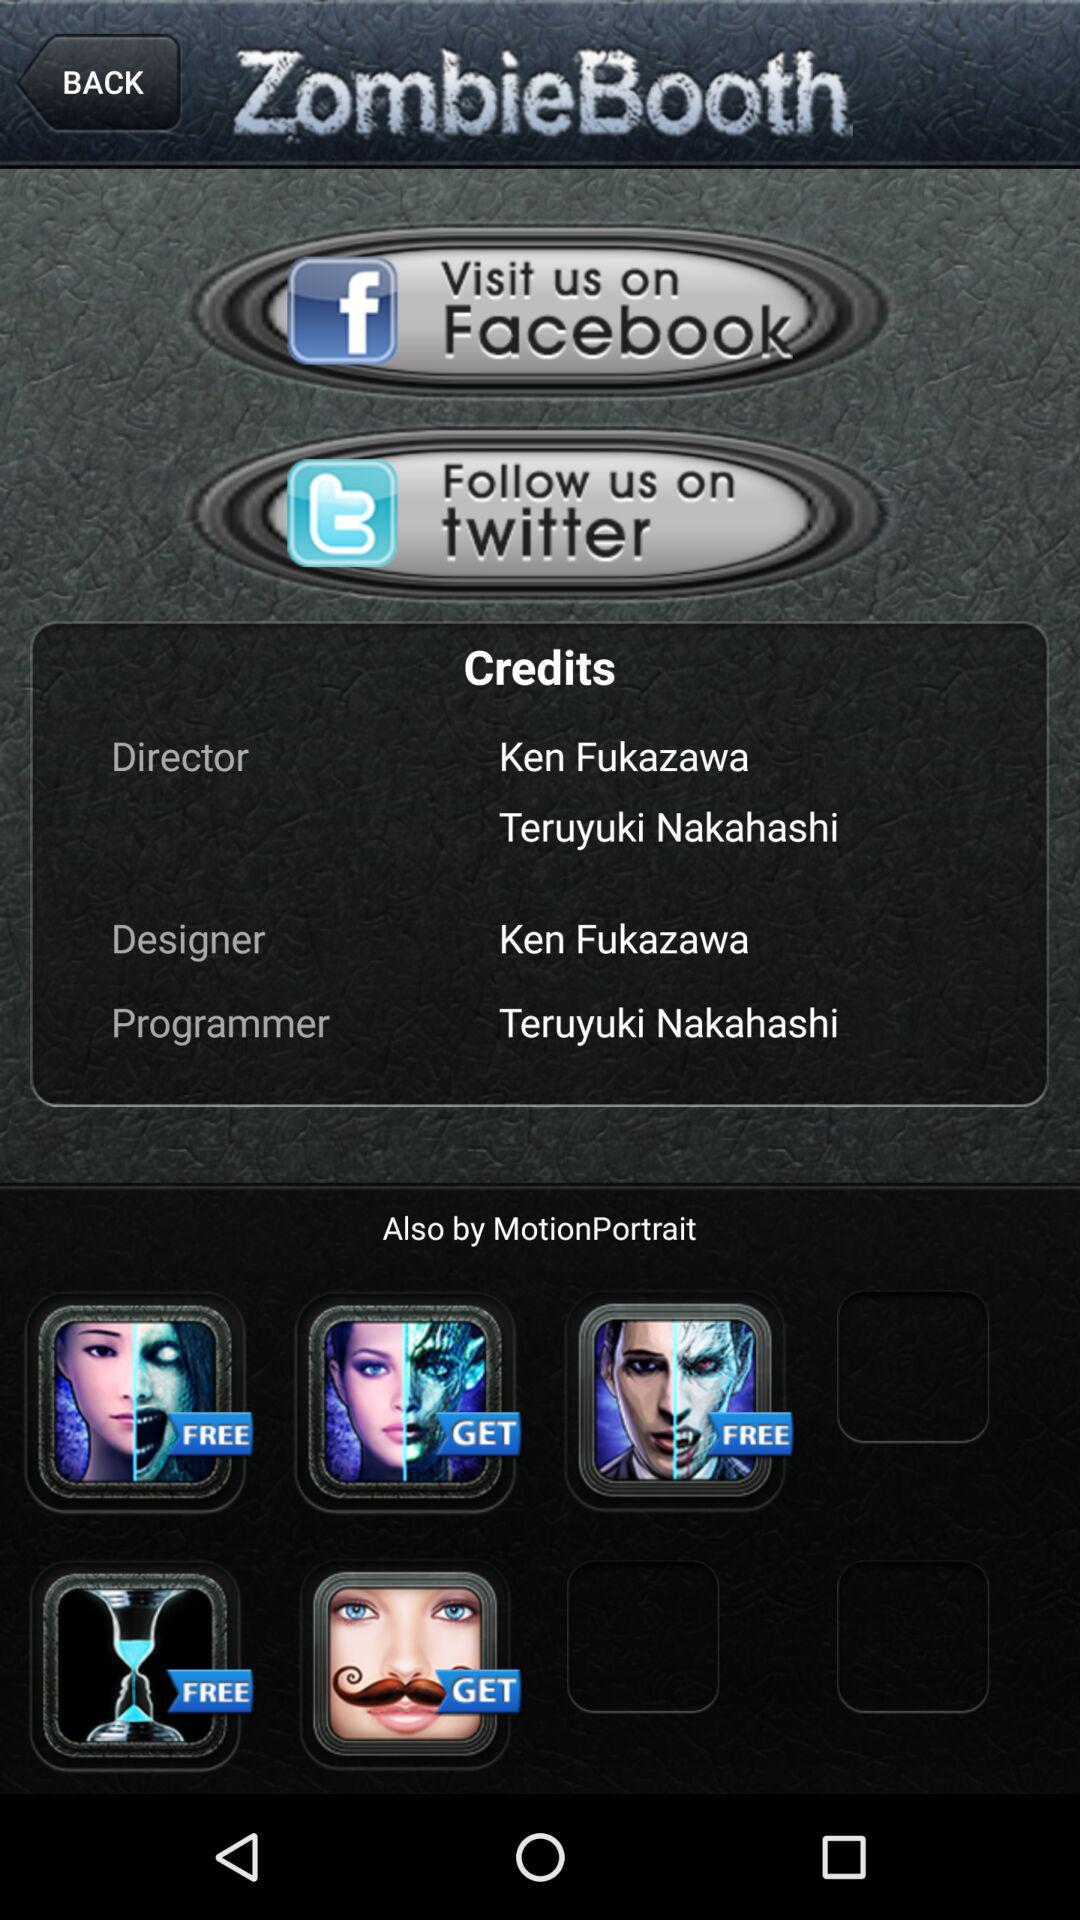What is the application name? The application name is "ZombieBooth". 